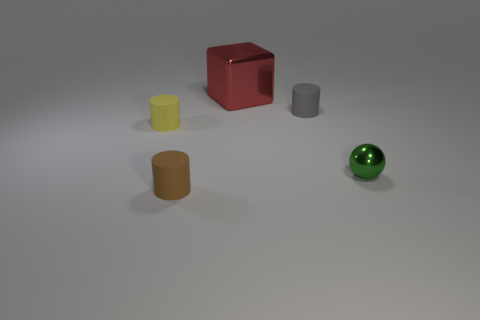What textures are visible on the objects in the image? The objects appear to have fairly smooth surfaces with a diffuse reflection, which suggests a matte or satin finish. The lighting in the image highlights the gentle curvature of the objects, enhancing their three-dimensional appearance. 